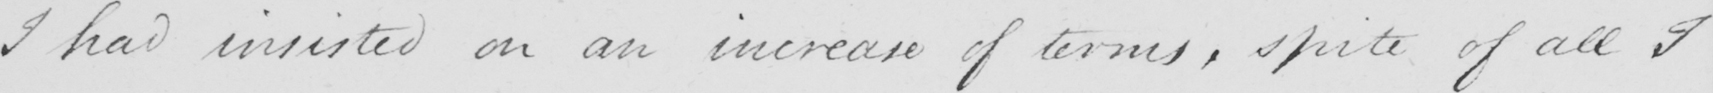Please provide the text content of this handwritten line. I had insisted on an increase of terms , spite of all I 